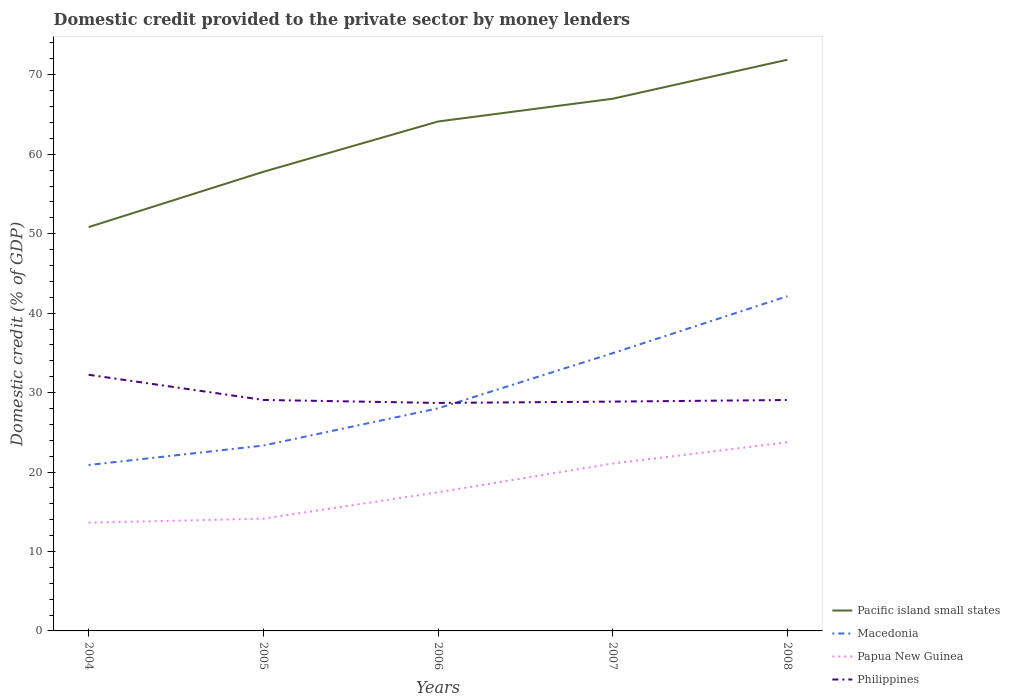How many different coloured lines are there?
Ensure brevity in your answer.  4. Across all years, what is the maximum domestic credit provided to the private sector by money lenders in Papua New Guinea?
Keep it short and to the point. 13.62. What is the total domestic credit provided to the private sector by money lenders in Philippines in the graph?
Keep it short and to the point. 0.21. What is the difference between the highest and the second highest domestic credit provided to the private sector by money lenders in Papua New Guinea?
Ensure brevity in your answer.  10.12. How many lines are there?
Your answer should be very brief. 4. How many years are there in the graph?
Provide a short and direct response. 5. What is the difference between two consecutive major ticks on the Y-axis?
Your answer should be very brief. 10. Are the values on the major ticks of Y-axis written in scientific E-notation?
Ensure brevity in your answer.  No. How are the legend labels stacked?
Provide a short and direct response. Vertical. What is the title of the graph?
Provide a short and direct response. Domestic credit provided to the private sector by money lenders. What is the label or title of the X-axis?
Give a very brief answer. Years. What is the label or title of the Y-axis?
Give a very brief answer. Domestic credit (% of GDP). What is the Domestic credit (% of GDP) in Pacific island small states in 2004?
Your answer should be compact. 50.83. What is the Domestic credit (% of GDP) of Macedonia in 2004?
Keep it short and to the point. 20.88. What is the Domestic credit (% of GDP) of Papua New Guinea in 2004?
Provide a succinct answer. 13.62. What is the Domestic credit (% of GDP) of Philippines in 2004?
Offer a very short reply. 32.24. What is the Domestic credit (% of GDP) of Pacific island small states in 2005?
Provide a short and direct response. 57.79. What is the Domestic credit (% of GDP) in Macedonia in 2005?
Your response must be concise. 23.33. What is the Domestic credit (% of GDP) in Papua New Guinea in 2005?
Make the answer very short. 14.13. What is the Domestic credit (% of GDP) of Philippines in 2005?
Make the answer very short. 29.07. What is the Domestic credit (% of GDP) in Pacific island small states in 2006?
Your response must be concise. 64.12. What is the Domestic credit (% of GDP) in Macedonia in 2006?
Keep it short and to the point. 28.01. What is the Domestic credit (% of GDP) in Papua New Guinea in 2006?
Make the answer very short. 17.45. What is the Domestic credit (% of GDP) of Philippines in 2006?
Make the answer very short. 28.69. What is the Domestic credit (% of GDP) of Pacific island small states in 2007?
Your response must be concise. 66.99. What is the Domestic credit (% of GDP) in Macedonia in 2007?
Offer a very short reply. 34.96. What is the Domestic credit (% of GDP) in Papua New Guinea in 2007?
Your answer should be very brief. 21.07. What is the Domestic credit (% of GDP) of Philippines in 2007?
Keep it short and to the point. 28.86. What is the Domestic credit (% of GDP) in Pacific island small states in 2008?
Provide a short and direct response. 71.89. What is the Domestic credit (% of GDP) of Macedonia in 2008?
Offer a very short reply. 42.13. What is the Domestic credit (% of GDP) in Papua New Guinea in 2008?
Offer a very short reply. 23.74. What is the Domestic credit (% of GDP) in Philippines in 2008?
Your answer should be compact. 29.06. Across all years, what is the maximum Domestic credit (% of GDP) in Pacific island small states?
Your response must be concise. 71.89. Across all years, what is the maximum Domestic credit (% of GDP) of Macedonia?
Make the answer very short. 42.13. Across all years, what is the maximum Domestic credit (% of GDP) in Papua New Guinea?
Your answer should be compact. 23.74. Across all years, what is the maximum Domestic credit (% of GDP) in Philippines?
Provide a succinct answer. 32.24. Across all years, what is the minimum Domestic credit (% of GDP) in Pacific island small states?
Give a very brief answer. 50.83. Across all years, what is the minimum Domestic credit (% of GDP) in Macedonia?
Keep it short and to the point. 20.88. Across all years, what is the minimum Domestic credit (% of GDP) of Papua New Guinea?
Offer a very short reply. 13.62. Across all years, what is the minimum Domestic credit (% of GDP) of Philippines?
Your answer should be compact. 28.69. What is the total Domestic credit (% of GDP) of Pacific island small states in the graph?
Your response must be concise. 311.61. What is the total Domestic credit (% of GDP) of Macedonia in the graph?
Offer a terse response. 149.32. What is the total Domestic credit (% of GDP) of Papua New Guinea in the graph?
Offer a terse response. 90.01. What is the total Domestic credit (% of GDP) in Philippines in the graph?
Give a very brief answer. 147.94. What is the difference between the Domestic credit (% of GDP) in Pacific island small states in 2004 and that in 2005?
Provide a short and direct response. -6.96. What is the difference between the Domestic credit (% of GDP) of Macedonia in 2004 and that in 2005?
Offer a very short reply. -2.45. What is the difference between the Domestic credit (% of GDP) of Papua New Guinea in 2004 and that in 2005?
Offer a terse response. -0.51. What is the difference between the Domestic credit (% of GDP) of Philippines in 2004 and that in 2005?
Your answer should be compact. 3.17. What is the difference between the Domestic credit (% of GDP) of Pacific island small states in 2004 and that in 2006?
Provide a succinct answer. -13.29. What is the difference between the Domestic credit (% of GDP) in Macedonia in 2004 and that in 2006?
Offer a terse response. -7.13. What is the difference between the Domestic credit (% of GDP) of Papua New Guinea in 2004 and that in 2006?
Your answer should be compact. -3.83. What is the difference between the Domestic credit (% of GDP) of Philippines in 2004 and that in 2006?
Ensure brevity in your answer.  3.55. What is the difference between the Domestic credit (% of GDP) of Pacific island small states in 2004 and that in 2007?
Ensure brevity in your answer.  -16.16. What is the difference between the Domestic credit (% of GDP) of Macedonia in 2004 and that in 2007?
Offer a terse response. -14.08. What is the difference between the Domestic credit (% of GDP) in Papua New Guinea in 2004 and that in 2007?
Provide a short and direct response. -7.44. What is the difference between the Domestic credit (% of GDP) of Philippines in 2004 and that in 2007?
Provide a short and direct response. 3.38. What is the difference between the Domestic credit (% of GDP) in Pacific island small states in 2004 and that in 2008?
Provide a succinct answer. -21.07. What is the difference between the Domestic credit (% of GDP) in Macedonia in 2004 and that in 2008?
Your response must be concise. -21.24. What is the difference between the Domestic credit (% of GDP) of Papua New Guinea in 2004 and that in 2008?
Offer a terse response. -10.12. What is the difference between the Domestic credit (% of GDP) of Philippines in 2004 and that in 2008?
Ensure brevity in your answer.  3.18. What is the difference between the Domestic credit (% of GDP) in Pacific island small states in 2005 and that in 2006?
Ensure brevity in your answer.  -6.33. What is the difference between the Domestic credit (% of GDP) of Macedonia in 2005 and that in 2006?
Provide a succinct answer. -4.68. What is the difference between the Domestic credit (% of GDP) in Papua New Guinea in 2005 and that in 2006?
Offer a very short reply. -3.32. What is the difference between the Domestic credit (% of GDP) of Philippines in 2005 and that in 2006?
Your response must be concise. 0.38. What is the difference between the Domestic credit (% of GDP) in Pacific island small states in 2005 and that in 2007?
Provide a succinct answer. -9.2. What is the difference between the Domestic credit (% of GDP) in Macedonia in 2005 and that in 2007?
Ensure brevity in your answer.  -11.63. What is the difference between the Domestic credit (% of GDP) of Papua New Guinea in 2005 and that in 2007?
Give a very brief answer. -6.94. What is the difference between the Domestic credit (% of GDP) in Philippines in 2005 and that in 2007?
Keep it short and to the point. 0.21. What is the difference between the Domestic credit (% of GDP) in Pacific island small states in 2005 and that in 2008?
Provide a succinct answer. -14.11. What is the difference between the Domestic credit (% of GDP) of Macedonia in 2005 and that in 2008?
Keep it short and to the point. -18.8. What is the difference between the Domestic credit (% of GDP) of Papua New Guinea in 2005 and that in 2008?
Provide a succinct answer. -9.61. What is the difference between the Domestic credit (% of GDP) of Philippines in 2005 and that in 2008?
Give a very brief answer. 0.01. What is the difference between the Domestic credit (% of GDP) of Pacific island small states in 2006 and that in 2007?
Offer a terse response. -2.87. What is the difference between the Domestic credit (% of GDP) in Macedonia in 2006 and that in 2007?
Provide a short and direct response. -6.95. What is the difference between the Domestic credit (% of GDP) in Papua New Guinea in 2006 and that in 2007?
Your answer should be compact. -3.62. What is the difference between the Domestic credit (% of GDP) in Philippines in 2006 and that in 2007?
Keep it short and to the point. -0.17. What is the difference between the Domestic credit (% of GDP) of Pacific island small states in 2006 and that in 2008?
Your answer should be very brief. -7.78. What is the difference between the Domestic credit (% of GDP) in Macedonia in 2006 and that in 2008?
Make the answer very short. -14.11. What is the difference between the Domestic credit (% of GDP) in Papua New Guinea in 2006 and that in 2008?
Keep it short and to the point. -6.29. What is the difference between the Domestic credit (% of GDP) in Philippines in 2006 and that in 2008?
Your answer should be very brief. -0.37. What is the difference between the Domestic credit (% of GDP) in Pacific island small states in 2007 and that in 2008?
Make the answer very short. -4.91. What is the difference between the Domestic credit (% of GDP) of Macedonia in 2007 and that in 2008?
Your response must be concise. -7.17. What is the difference between the Domestic credit (% of GDP) of Papua New Guinea in 2007 and that in 2008?
Your response must be concise. -2.67. What is the difference between the Domestic credit (% of GDP) in Philippines in 2007 and that in 2008?
Offer a terse response. -0.2. What is the difference between the Domestic credit (% of GDP) of Pacific island small states in 2004 and the Domestic credit (% of GDP) of Macedonia in 2005?
Ensure brevity in your answer.  27.5. What is the difference between the Domestic credit (% of GDP) in Pacific island small states in 2004 and the Domestic credit (% of GDP) in Papua New Guinea in 2005?
Provide a short and direct response. 36.7. What is the difference between the Domestic credit (% of GDP) in Pacific island small states in 2004 and the Domestic credit (% of GDP) in Philippines in 2005?
Offer a terse response. 21.76. What is the difference between the Domestic credit (% of GDP) of Macedonia in 2004 and the Domestic credit (% of GDP) of Papua New Guinea in 2005?
Provide a short and direct response. 6.75. What is the difference between the Domestic credit (% of GDP) in Macedonia in 2004 and the Domestic credit (% of GDP) in Philippines in 2005?
Ensure brevity in your answer.  -8.19. What is the difference between the Domestic credit (% of GDP) of Papua New Guinea in 2004 and the Domestic credit (% of GDP) of Philippines in 2005?
Give a very brief answer. -15.45. What is the difference between the Domestic credit (% of GDP) of Pacific island small states in 2004 and the Domestic credit (% of GDP) of Macedonia in 2006?
Ensure brevity in your answer.  22.81. What is the difference between the Domestic credit (% of GDP) in Pacific island small states in 2004 and the Domestic credit (% of GDP) in Papua New Guinea in 2006?
Ensure brevity in your answer.  33.38. What is the difference between the Domestic credit (% of GDP) in Pacific island small states in 2004 and the Domestic credit (% of GDP) in Philippines in 2006?
Provide a short and direct response. 22.13. What is the difference between the Domestic credit (% of GDP) in Macedonia in 2004 and the Domestic credit (% of GDP) in Papua New Guinea in 2006?
Offer a terse response. 3.43. What is the difference between the Domestic credit (% of GDP) in Macedonia in 2004 and the Domestic credit (% of GDP) in Philippines in 2006?
Your answer should be compact. -7.81. What is the difference between the Domestic credit (% of GDP) in Papua New Guinea in 2004 and the Domestic credit (% of GDP) in Philippines in 2006?
Make the answer very short. -15.07. What is the difference between the Domestic credit (% of GDP) in Pacific island small states in 2004 and the Domestic credit (% of GDP) in Macedonia in 2007?
Give a very brief answer. 15.87. What is the difference between the Domestic credit (% of GDP) in Pacific island small states in 2004 and the Domestic credit (% of GDP) in Papua New Guinea in 2007?
Your response must be concise. 29.76. What is the difference between the Domestic credit (% of GDP) of Pacific island small states in 2004 and the Domestic credit (% of GDP) of Philippines in 2007?
Your answer should be very brief. 21.96. What is the difference between the Domestic credit (% of GDP) of Macedonia in 2004 and the Domestic credit (% of GDP) of Papua New Guinea in 2007?
Your answer should be very brief. -0.18. What is the difference between the Domestic credit (% of GDP) of Macedonia in 2004 and the Domestic credit (% of GDP) of Philippines in 2007?
Your answer should be compact. -7.98. What is the difference between the Domestic credit (% of GDP) of Papua New Guinea in 2004 and the Domestic credit (% of GDP) of Philippines in 2007?
Provide a short and direct response. -15.24. What is the difference between the Domestic credit (% of GDP) of Pacific island small states in 2004 and the Domestic credit (% of GDP) of Macedonia in 2008?
Provide a succinct answer. 8.7. What is the difference between the Domestic credit (% of GDP) in Pacific island small states in 2004 and the Domestic credit (% of GDP) in Papua New Guinea in 2008?
Ensure brevity in your answer.  27.09. What is the difference between the Domestic credit (% of GDP) of Pacific island small states in 2004 and the Domestic credit (% of GDP) of Philippines in 2008?
Your response must be concise. 21.76. What is the difference between the Domestic credit (% of GDP) of Macedonia in 2004 and the Domestic credit (% of GDP) of Papua New Guinea in 2008?
Your response must be concise. -2.86. What is the difference between the Domestic credit (% of GDP) of Macedonia in 2004 and the Domestic credit (% of GDP) of Philippines in 2008?
Keep it short and to the point. -8.18. What is the difference between the Domestic credit (% of GDP) in Papua New Guinea in 2004 and the Domestic credit (% of GDP) in Philippines in 2008?
Give a very brief answer. -15.44. What is the difference between the Domestic credit (% of GDP) in Pacific island small states in 2005 and the Domestic credit (% of GDP) in Macedonia in 2006?
Ensure brevity in your answer.  29.77. What is the difference between the Domestic credit (% of GDP) in Pacific island small states in 2005 and the Domestic credit (% of GDP) in Papua New Guinea in 2006?
Offer a very short reply. 40.34. What is the difference between the Domestic credit (% of GDP) of Pacific island small states in 2005 and the Domestic credit (% of GDP) of Philippines in 2006?
Ensure brevity in your answer.  29.09. What is the difference between the Domestic credit (% of GDP) of Macedonia in 2005 and the Domestic credit (% of GDP) of Papua New Guinea in 2006?
Offer a terse response. 5.88. What is the difference between the Domestic credit (% of GDP) in Macedonia in 2005 and the Domestic credit (% of GDP) in Philippines in 2006?
Offer a very short reply. -5.36. What is the difference between the Domestic credit (% of GDP) in Papua New Guinea in 2005 and the Domestic credit (% of GDP) in Philippines in 2006?
Provide a short and direct response. -14.56. What is the difference between the Domestic credit (% of GDP) in Pacific island small states in 2005 and the Domestic credit (% of GDP) in Macedonia in 2007?
Provide a short and direct response. 22.83. What is the difference between the Domestic credit (% of GDP) in Pacific island small states in 2005 and the Domestic credit (% of GDP) in Papua New Guinea in 2007?
Your answer should be compact. 36.72. What is the difference between the Domestic credit (% of GDP) of Pacific island small states in 2005 and the Domestic credit (% of GDP) of Philippines in 2007?
Your answer should be very brief. 28.92. What is the difference between the Domestic credit (% of GDP) in Macedonia in 2005 and the Domestic credit (% of GDP) in Papua New Guinea in 2007?
Make the answer very short. 2.26. What is the difference between the Domestic credit (% of GDP) of Macedonia in 2005 and the Domestic credit (% of GDP) of Philippines in 2007?
Offer a very short reply. -5.53. What is the difference between the Domestic credit (% of GDP) in Papua New Guinea in 2005 and the Domestic credit (% of GDP) in Philippines in 2007?
Your response must be concise. -14.73. What is the difference between the Domestic credit (% of GDP) in Pacific island small states in 2005 and the Domestic credit (% of GDP) in Macedonia in 2008?
Provide a succinct answer. 15.66. What is the difference between the Domestic credit (% of GDP) of Pacific island small states in 2005 and the Domestic credit (% of GDP) of Papua New Guinea in 2008?
Offer a terse response. 34.05. What is the difference between the Domestic credit (% of GDP) of Pacific island small states in 2005 and the Domestic credit (% of GDP) of Philippines in 2008?
Give a very brief answer. 28.72. What is the difference between the Domestic credit (% of GDP) in Macedonia in 2005 and the Domestic credit (% of GDP) in Papua New Guinea in 2008?
Your answer should be very brief. -0.41. What is the difference between the Domestic credit (% of GDP) of Macedonia in 2005 and the Domestic credit (% of GDP) of Philippines in 2008?
Give a very brief answer. -5.73. What is the difference between the Domestic credit (% of GDP) of Papua New Guinea in 2005 and the Domestic credit (% of GDP) of Philippines in 2008?
Your answer should be compact. -14.94. What is the difference between the Domestic credit (% of GDP) in Pacific island small states in 2006 and the Domestic credit (% of GDP) in Macedonia in 2007?
Make the answer very short. 29.16. What is the difference between the Domestic credit (% of GDP) of Pacific island small states in 2006 and the Domestic credit (% of GDP) of Papua New Guinea in 2007?
Your answer should be very brief. 43.05. What is the difference between the Domestic credit (% of GDP) in Pacific island small states in 2006 and the Domestic credit (% of GDP) in Philippines in 2007?
Ensure brevity in your answer.  35.25. What is the difference between the Domestic credit (% of GDP) in Macedonia in 2006 and the Domestic credit (% of GDP) in Papua New Guinea in 2007?
Ensure brevity in your answer.  6.95. What is the difference between the Domestic credit (% of GDP) of Macedonia in 2006 and the Domestic credit (% of GDP) of Philippines in 2007?
Offer a terse response. -0.85. What is the difference between the Domestic credit (% of GDP) of Papua New Guinea in 2006 and the Domestic credit (% of GDP) of Philippines in 2007?
Keep it short and to the point. -11.41. What is the difference between the Domestic credit (% of GDP) in Pacific island small states in 2006 and the Domestic credit (% of GDP) in Macedonia in 2008?
Give a very brief answer. 21.99. What is the difference between the Domestic credit (% of GDP) in Pacific island small states in 2006 and the Domestic credit (% of GDP) in Papua New Guinea in 2008?
Ensure brevity in your answer.  40.38. What is the difference between the Domestic credit (% of GDP) in Pacific island small states in 2006 and the Domestic credit (% of GDP) in Philippines in 2008?
Provide a short and direct response. 35.05. What is the difference between the Domestic credit (% of GDP) in Macedonia in 2006 and the Domestic credit (% of GDP) in Papua New Guinea in 2008?
Offer a terse response. 4.27. What is the difference between the Domestic credit (% of GDP) in Macedonia in 2006 and the Domestic credit (% of GDP) in Philippines in 2008?
Your response must be concise. -1.05. What is the difference between the Domestic credit (% of GDP) in Papua New Guinea in 2006 and the Domestic credit (% of GDP) in Philippines in 2008?
Your answer should be compact. -11.61. What is the difference between the Domestic credit (% of GDP) in Pacific island small states in 2007 and the Domestic credit (% of GDP) in Macedonia in 2008?
Your answer should be very brief. 24.86. What is the difference between the Domestic credit (% of GDP) in Pacific island small states in 2007 and the Domestic credit (% of GDP) in Papua New Guinea in 2008?
Make the answer very short. 43.24. What is the difference between the Domestic credit (% of GDP) of Pacific island small states in 2007 and the Domestic credit (% of GDP) of Philippines in 2008?
Your answer should be compact. 37.92. What is the difference between the Domestic credit (% of GDP) in Macedonia in 2007 and the Domestic credit (% of GDP) in Papua New Guinea in 2008?
Provide a succinct answer. 11.22. What is the difference between the Domestic credit (% of GDP) of Macedonia in 2007 and the Domestic credit (% of GDP) of Philippines in 2008?
Give a very brief answer. 5.9. What is the difference between the Domestic credit (% of GDP) of Papua New Guinea in 2007 and the Domestic credit (% of GDP) of Philippines in 2008?
Keep it short and to the point. -8. What is the average Domestic credit (% of GDP) in Pacific island small states per year?
Provide a succinct answer. 62.32. What is the average Domestic credit (% of GDP) of Macedonia per year?
Provide a short and direct response. 29.86. What is the average Domestic credit (% of GDP) in Papua New Guinea per year?
Provide a succinct answer. 18. What is the average Domestic credit (% of GDP) in Philippines per year?
Offer a very short reply. 29.59. In the year 2004, what is the difference between the Domestic credit (% of GDP) of Pacific island small states and Domestic credit (% of GDP) of Macedonia?
Offer a very short reply. 29.94. In the year 2004, what is the difference between the Domestic credit (% of GDP) of Pacific island small states and Domestic credit (% of GDP) of Papua New Guinea?
Your response must be concise. 37.21. In the year 2004, what is the difference between the Domestic credit (% of GDP) of Pacific island small states and Domestic credit (% of GDP) of Philippines?
Give a very brief answer. 18.59. In the year 2004, what is the difference between the Domestic credit (% of GDP) of Macedonia and Domestic credit (% of GDP) of Papua New Guinea?
Provide a succinct answer. 7.26. In the year 2004, what is the difference between the Domestic credit (% of GDP) of Macedonia and Domestic credit (% of GDP) of Philippines?
Your answer should be very brief. -11.36. In the year 2004, what is the difference between the Domestic credit (% of GDP) in Papua New Guinea and Domestic credit (% of GDP) in Philippines?
Offer a very short reply. -18.62. In the year 2005, what is the difference between the Domestic credit (% of GDP) in Pacific island small states and Domestic credit (% of GDP) in Macedonia?
Your response must be concise. 34.46. In the year 2005, what is the difference between the Domestic credit (% of GDP) in Pacific island small states and Domestic credit (% of GDP) in Papua New Guinea?
Provide a succinct answer. 43.66. In the year 2005, what is the difference between the Domestic credit (% of GDP) of Pacific island small states and Domestic credit (% of GDP) of Philippines?
Your response must be concise. 28.71. In the year 2005, what is the difference between the Domestic credit (% of GDP) in Macedonia and Domestic credit (% of GDP) in Papua New Guinea?
Make the answer very short. 9.2. In the year 2005, what is the difference between the Domestic credit (% of GDP) of Macedonia and Domestic credit (% of GDP) of Philippines?
Provide a succinct answer. -5.74. In the year 2005, what is the difference between the Domestic credit (% of GDP) in Papua New Guinea and Domestic credit (% of GDP) in Philippines?
Offer a very short reply. -14.94. In the year 2006, what is the difference between the Domestic credit (% of GDP) of Pacific island small states and Domestic credit (% of GDP) of Macedonia?
Provide a short and direct response. 36.1. In the year 2006, what is the difference between the Domestic credit (% of GDP) in Pacific island small states and Domestic credit (% of GDP) in Papua New Guinea?
Offer a terse response. 46.67. In the year 2006, what is the difference between the Domestic credit (% of GDP) in Pacific island small states and Domestic credit (% of GDP) in Philippines?
Offer a terse response. 35.42. In the year 2006, what is the difference between the Domestic credit (% of GDP) in Macedonia and Domestic credit (% of GDP) in Papua New Guinea?
Ensure brevity in your answer.  10.56. In the year 2006, what is the difference between the Domestic credit (% of GDP) in Macedonia and Domestic credit (% of GDP) in Philippines?
Offer a terse response. -0.68. In the year 2006, what is the difference between the Domestic credit (% of GDP) in Papua New Guinea and Domestic credit (% of GDP) in Philippines?
Your response must be concise. -11.24. In the year 2007, what is the difference between the Domestic credit (% of GDP) in Pacific island small states and Domestic credit (% of GDP) in Macedonia?
Make the answer very short. 32.02. In the year 2007, what is the difference between the Domestic credit (% of GDP) of Pacific island small states and Domestic credit (% of GDP) of Papua New Guinea?
Your response must be concise. 45.92. In the year 2007, what is the difference between the Domestic credit (% of GDP) of Pacific island small states and Domestic credit (% of GDP) of Philippines?
Keep it short and to the point. 38.12. In the year 2007, what is the difference between the Domestic credit (% of GDP) in Macedonia and Domestic credit (% of GDP) in Papua New Guinea?
Offer a very short reply. 13.89. In the year 2007, what is the difference between the Domestic credit (% of GDP) in Macedonia and Domestic credit (% of GDP) in Philippines?
Your answer should be compact. 6.1. In the year 2007, what is the difference between the Domestic credit (% of GDP) of Papua New Guinea and Domestic credit (% of GDP) of Philippines?
Ensure brevity in your answer.  -7.8. In the year 2008, what is the difference between the Domestic credit (% of GDP) of Pacific island small states and Domestic credit (% of GDP) of Macedonia?
Provide a short and direct response. 29.77. In the year 2008, what is the difference between the Domestic credit (% of GDP) in Pacific island small states and Domestic credit (% of GDP) in Papua New Guinea?
Provide a short and direct response. 48.15. In the year 2008, what is the difference between the Domestic credit (% of GDP) of Pacific island small states and Domestic credit (% of GDP) of Philippines?
Your answer should be compact. 42.83. In the year 2008, what is the difference between the Domestic credit (% of GDP) of Macedonia and Domestic credit (% of GDP) of Papua New Guinea?
Offer a terse response. 18.39. In the year 2008, what is the difference between the Domestic credit (% of GDP) of Macedonia and Domestic credit (% of GDP) of Philippines?
Your answer should be compact. 13.06. In the year 2008, what is the difference between the Domestic credit (% of GDP) in Papua New Guinea and Domestic credit (% of GDP) in Philippines?
Provide a succinct answer. -5.32. What is the ratio of the Domestic credit (% of GDP) in Pacific island small states in 2004 to that in 2005?
Your answer should be compact. 0.88. What is the ratio of the Domestic credit (% of GDP) in Macedonia in 2004 to that in 2005?
Offer a very short reply. 0.9. What is the ratio of the Domestic credit (% of GDP) of Papua New Guinea in 2004 to that in 2005?
Your answer should be very brief. 0.96. What is the ratio of the Domestic credit (% of GDP) in Philippines in 2004 to that in 2005?
Offer a terse response. 1.11. What is the ratio of the Domestic credit (% of GDP) in Pacific island small states in 2004 to that in 2006?
Keep it short and to the point. 0.79. What is the ratio of the Domestic credit (% of GDP) in Macedonia in 2004 to that in 2006?
Provide a succinct answer. 0.75. What is the ratio of the Domestic credit (% of GDP) of Papua New Guinea in 2004 to that in 2006?
Provide a succinct answer. 0.78. What is the ratio of the Domestic credit (% of GDP) in Philippines in 2004 to that in 2006?
Your answer should be compact. 1.12. What is the ratio of the Domestic credit (% of GDP) of Pacific island small states in 2004 to that in 2007?
Give a very brief answer. 0.76. What is the ratio of the Domestic credit (% of GDP) in Macedonia in 2004 to that in 2007?
Make the answer very short. 0.6. What is the ratio of the Domestic credit (% of GDP) of Papua New Guinea in 2004 to that in 2007?
Your answer should be very brief. 0.65. What is the ratio of the Domestic credit (% of GDP) of Philippines in 2004 to that in 2007?
Give a very brief answer. 1.12. What is the ratio of the Domestic credit (% of GDP) of Pacific island small states in 2004 to that in 2008?
Make the answer very short. 0.71. What is the ratio of the Domestic credit (% of GDP) in Macedonia in 2004 to that in 2008?
Your answer should be compact. 0.5. What is the ratio of the Domestic credit (% of GDP) in Papua New Guinea in 2004 to that in 2008?
Your answer should be very brief. 0.57. What is the ratio of the Domestic credit (% of GDP) of Philippines in 2004 to that in 2008?
Keep it short and to the point. 1.11. What is the ratio of the Domestic credit (% of GDP) in Pacific island small states in 2005 to that in 2006?
Keep it short and to the point. 0.9. What is the ratio of the Domestic credit (% of GDP) in Macedonia in 2005 to that in 2006?
Make the answer very short. 0.83. What is the ratio of the Domestic credit (% of GDP) of Papua New Guinea in 2005 to that in 2006?
Keep it short and to the point. 0.81. What is the ratio of the Domestic credit (% of GDP) of Philippines in 2005 to that in 2006?
Give a very brief answer. 1.01. What is the ratio of the Domestic credit (% of GDP) in Pacific island small states in 2005 to that in 2007?
Provide a short and direct response. 0.86. What is the ratio of the Domestic credit (% of GDP) in Macedonia in 2005 to that in 2007?
Provide a succinct answer. 0.67. What is the ratio of the Domestic credit (% of GDP) of Papua New Guinea in 2005 to that in 2007?
Keep it short and to the point. 0.67. What is the ratio of the Domestic credit (% of GDP) in Philippines in 2005 to that in 2007?
Ensure brevity in your answer.  1.01. What is the ratio of the Domestic credit (% of GDP) in Pacific island small states in 2005 to that in 2008?
Ensure brevity in your answer.  0.8. What is the ratio of the Domestic credit (% of GDP) of Macedonia in 2005 to that in 2008?
Provide a short and direct response. 0.55. What is the ratio of the Domestic credit (% of GDP) in Papua New Guinea in 2005 to that in 2008?
Give a very brief answer. 0.6. What is the ratio of the Domestic credit (% of GDP) of Pacific island small states in 2006 to that in 2007?
Make the answer very short. 0.96. What is the ratio of the Domestic credit (% of GDP) of Macedonia in 2006 to that in 2007?
Give a very brief answer. 0.8. What is the ratio of the Domestic credit (% of GDP) of Papua New Guinea in 2006 to that in 2007?
Ensure brevity in your answer.  0.83. What is the ratio of the Domestic credit (% of GDP) in Philippines in 2006 to that in 2007?
Your answer should be very brief. 0.99. What is the ratio of the Domestic credit (% of GDP) in Pacific island small states in 2006 to that in 2008?
Your answer should be compact. 0.89. What is the ratio of the Domestic credit (% of GDP) of Macedonia in 2006 to that in 2008?
Provide a succinct answer. 0.67. What is the ratio of the Domestic credit (% of GDP) of Papua New Guinea in 2006 to that in 2008?
Your answer should be very brief. 0.74. What is the ratio of the Domestic credit (% of GDP) of Philippines in 2006 to that in 2008?
Your answer should be compact. 0.99. What is the ratio of the Domestic credit (% of GDP) in Pacific island small states in 2007 to that in 2008?
Keep it short and to the point. 0.93. What is the ratio of the Domestic credit (% of GDP) in Macedonia in 2007 to that in 2008?
Provide a succinct answer. 0.83. What is the ratio of the Domestic credit (% of GDP) of Papua New Guinea in 2007 to that in 2008?
Offer a very short reply. 0.89. What is the ratio of the Domestic credit (% of GDP) of Philippines in 2007 to that in 2008?
Ensure brevity in your answer.  0.99. What is the difference between the highest and the second highest Domestic credit (% of GDP) of Pacific island small states?
Provide a succinct answer. 4.91. What is the difference between the highest and the second highest Domestic credit (% of GDP) in Macedonia?
Your answer should be very brief. 7.17. What is the difference between the highest and the second highest Domestic credit (% of GDP) of Papua New Guinea?
Your answer should be very brief. 2.67. What is the difference between the highest and the second highest Domestic credit (% of GDP) of Philippines?
Your answer should be compact. 3.17. What is the difference between the highest and the lowest Domestic credit (% of GDP) of Pacific island small states?
Your answer should be compact. 21.07. What is the difference between the highest and the lowest Domestic credit (% of GDP) in Macedonia?
Ensure brevity in your answer.  21.24. What is the difference between the highest and the lowest Domestic credit (% of GDP) in Papua New Guinea?
Keep it short and to the point. 10.12. What is the difference between the highest and the lowest Domestic credit (% of GDP) in Philippines?
Your answer should be very brief. 3.55. 